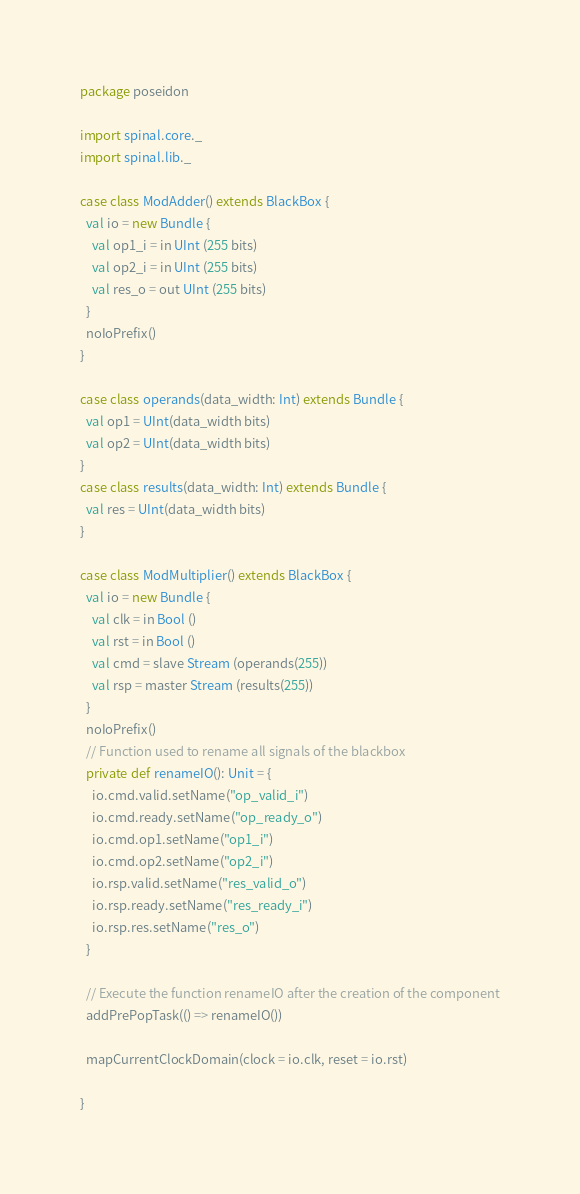Convert code to text. <code><loc_0><loc_0><loc_500><loc_500><_Scala_>package poseidon

import spinal.core._
import spinal.lib._

case class ModAdder() extends BlackBox {
  val io = new Bundle {
    val op1_i = in UInt (255 bits)
    val op2_i = in UInt (255 bits)
    val res_o = out UInt (255 bits)
  }
  noIoPrefix()
}

case class operands(data_width: Int) extends Bundle {
  val op1 = UInt(data_width bits)
  val op2 = UInt(data_width bits)
}
case class results(data_width: Int) extends Bundle {
  val res = UInt(data_width bits)
}

case class ModMultiplier() extends BlackBox {
  val io = new Bundle {
    val clk = in Bool ()
    val rst = in Bool ()
    val cmd = slave Stream (operands(255))
    val rsp = master Stream (results(255))
  }
  noIoPrefix()
  // Function used to rename all signals of the blackbox
  private def renameIO(): Unit = {
    io.cmd.valid.setName("op_valid_i")
    io.cmd.ready.setName("op_ready_o")
    io.cmd.op1.setName("op1_i")
    io.cmd.op2.setName("op2_i")
    io.rsp.valid.setName("res_valid_o")
    io.rsp.ready.setName("res_ready_i")
    io.rsp.res.setName("res_o")
  }

  // Execute the function renameIO after the creation of the component
  addPrePopTask(() => renameIO())

  mapCurrentClockDomain(clock = io.clk, reset = io.rst)

}
</code> 